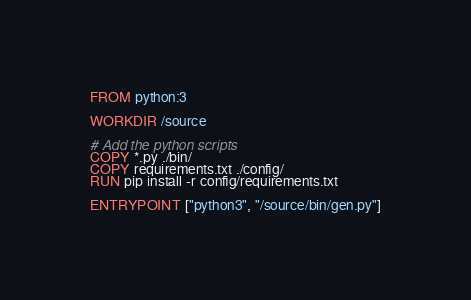<code> <loc_0><loc_0><loc_500><loc_500><_Dockerfile_>FROM python:3

WORKDIR /source

# Add the python scripts
COPY *.py ./bin/
COPY requirements.txt ./config/
RUN pip install -r config/requirements.txt 

ENTRYPOINT ["python3", "/source/bin/gen.py"]</code> 